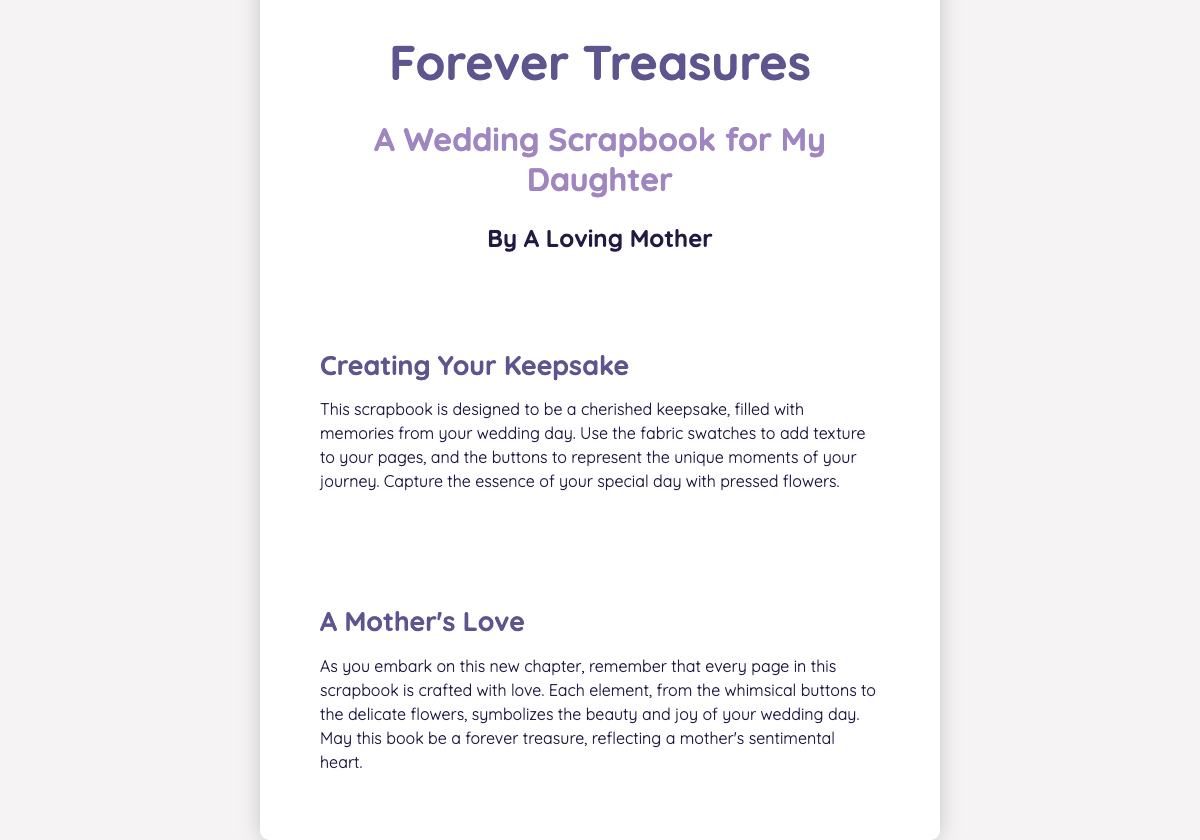What is the title of the book? The title is prominently displayed at the top of the book cover.
Answer: Forever Treasures Who is the author of the book? The author is mentioned below the subtitle.
Answer: A Loving Mother What type of scrapbook is this? The subtitle of the book specifies the theme of the scrapbook.
Answer: A Wedding Scrapbook What elements are mentioned to use in the scrapbook? The book describes several scrapbooking elements within the content.
Answer: Buttons, fabric swatches, pressed flowers What is the purpose of the scrapbook? The first section explains the intention behind creating the scrapbook.
Answer: To be a cherished keepsake What sentiment does the author convey in the second section? The second section focuses on the mother's feelings towards the scrapbook.
Answer: A mother's love What color is used for the section titles? The section titles in the document have a specific color that can be observed.
Answer: Dark purple What does the scrapbook encourage creating? The document explicitly mentions the type of book it aims to be.
Answer: A personalized keepsake book 